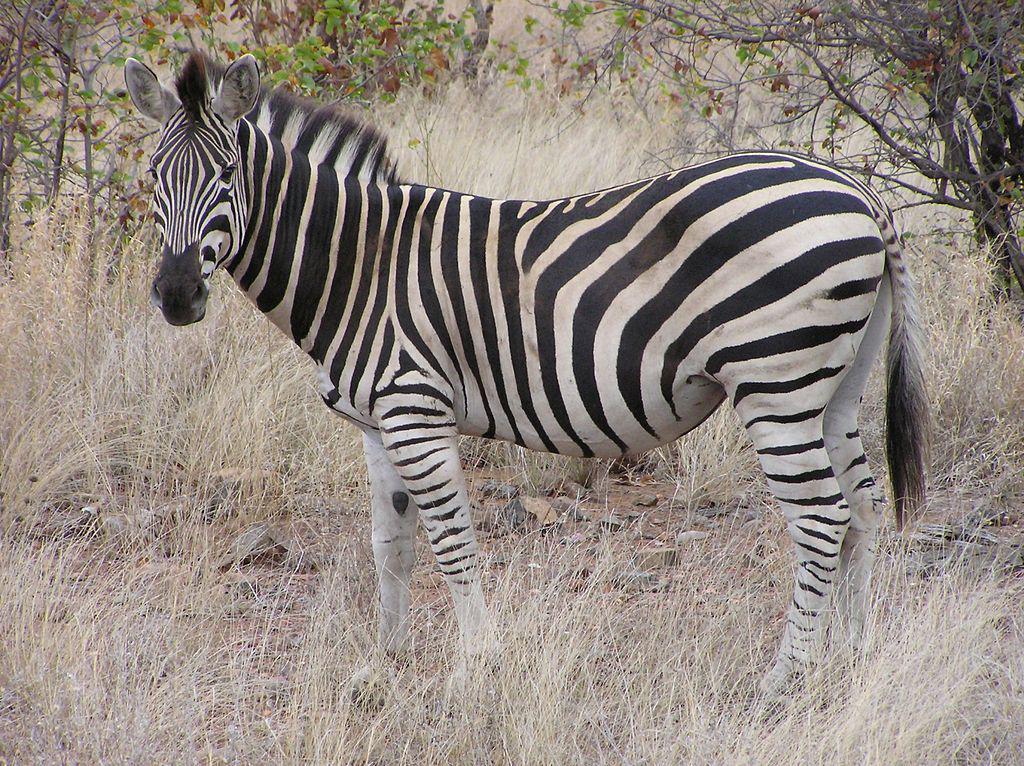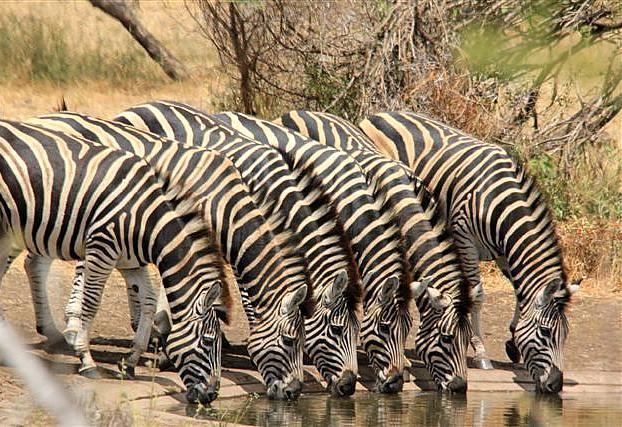The first image is the image on the left, the second image is the image on the right. For the images displayed, is the sentence "Two zebras are standing near each other in both pictures." factually correct? Answer yes or no. No. The first image is the image on the left, the second image is the image on the right. Considering the images on both sides, is "Each image contains exactly two zebras, and at least one image features two zebras standing one in front of the other and facing the same direction." valid? Answer yes or no. No. 